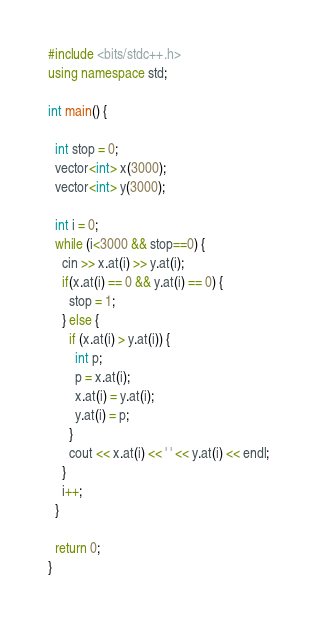Convert code to text. <code><loc_0><loc_0><loc_500><loc_500><_C++_>#include <bits/stdc++.h>
using namespace std;

int main() {

  int stop = 0;
  vector<int> x(3000);
  vector<int> y(3000);
  
  int i = 0;
  while (i<3000 && stop==0) {
    cin >> x.at(i) >> y.at(i);
    if(x.at(i) == 0 && y.at(i) == 0) {
	  stop = 1;
    } else {
	  if (x.at(i) > y.at(i)) {
        int p;
        p = x.at(i);
        x.at(i) = y.at(i);
        y.at(i) = p;
      }
      cout << x.at(i) << ' ' << y.at(i) << endl;
    }
    i++;
  }
  
  return 0;
}
</code> 